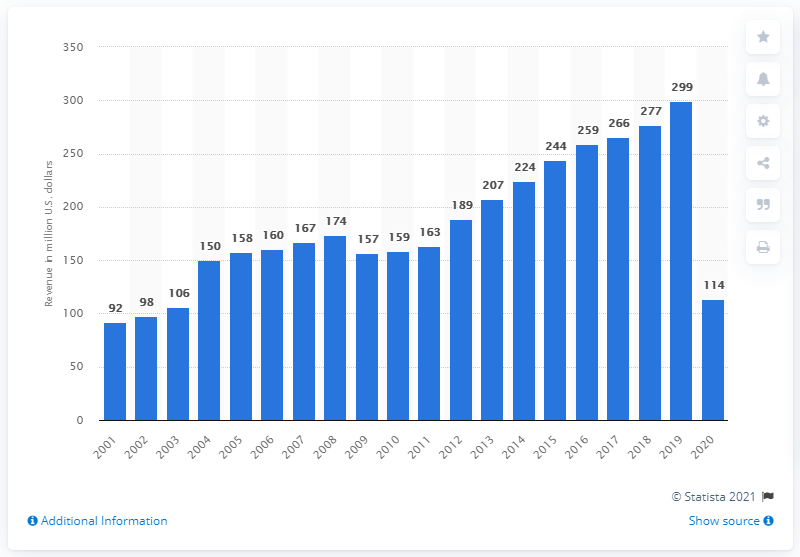Highlight a few significant elements in this photo. In 2020, the revenue of the San Diego Padres was $114 million. 